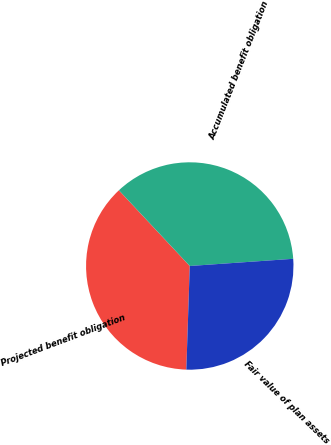Convert chart to OTSL. <chart><loc_0><loc_0><loc_500><loc_500><pie_chart><fcel>Projected benefit obligation<fcel>Accumulated benefit obligation<fcel>Fair value of plan assets<nl><fcel>37.5%<fcel>35.87%<fcel>26.63%<nl></chart> 